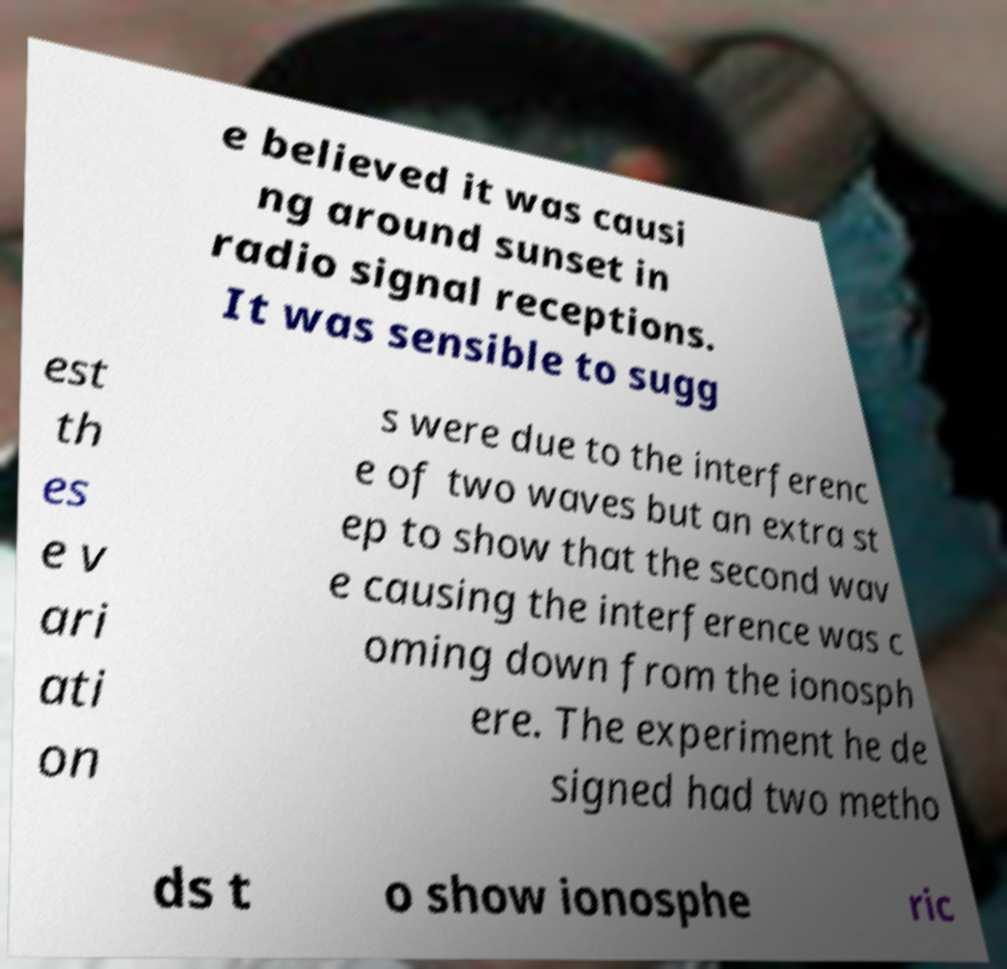There's text embedded in this image that I need extracted. Can you transcribe it verbatim? e believed it was causi ng around sunset in radio signal receptions. It was sensible to sugg est th es e v ari ati on s were due to the interferenc e of two waves but an extra st ep to show that the second wav e causing the interference was c oming down from the ionosph ere. The experiment he de signed had two metho ds t o show ionosphe ric 